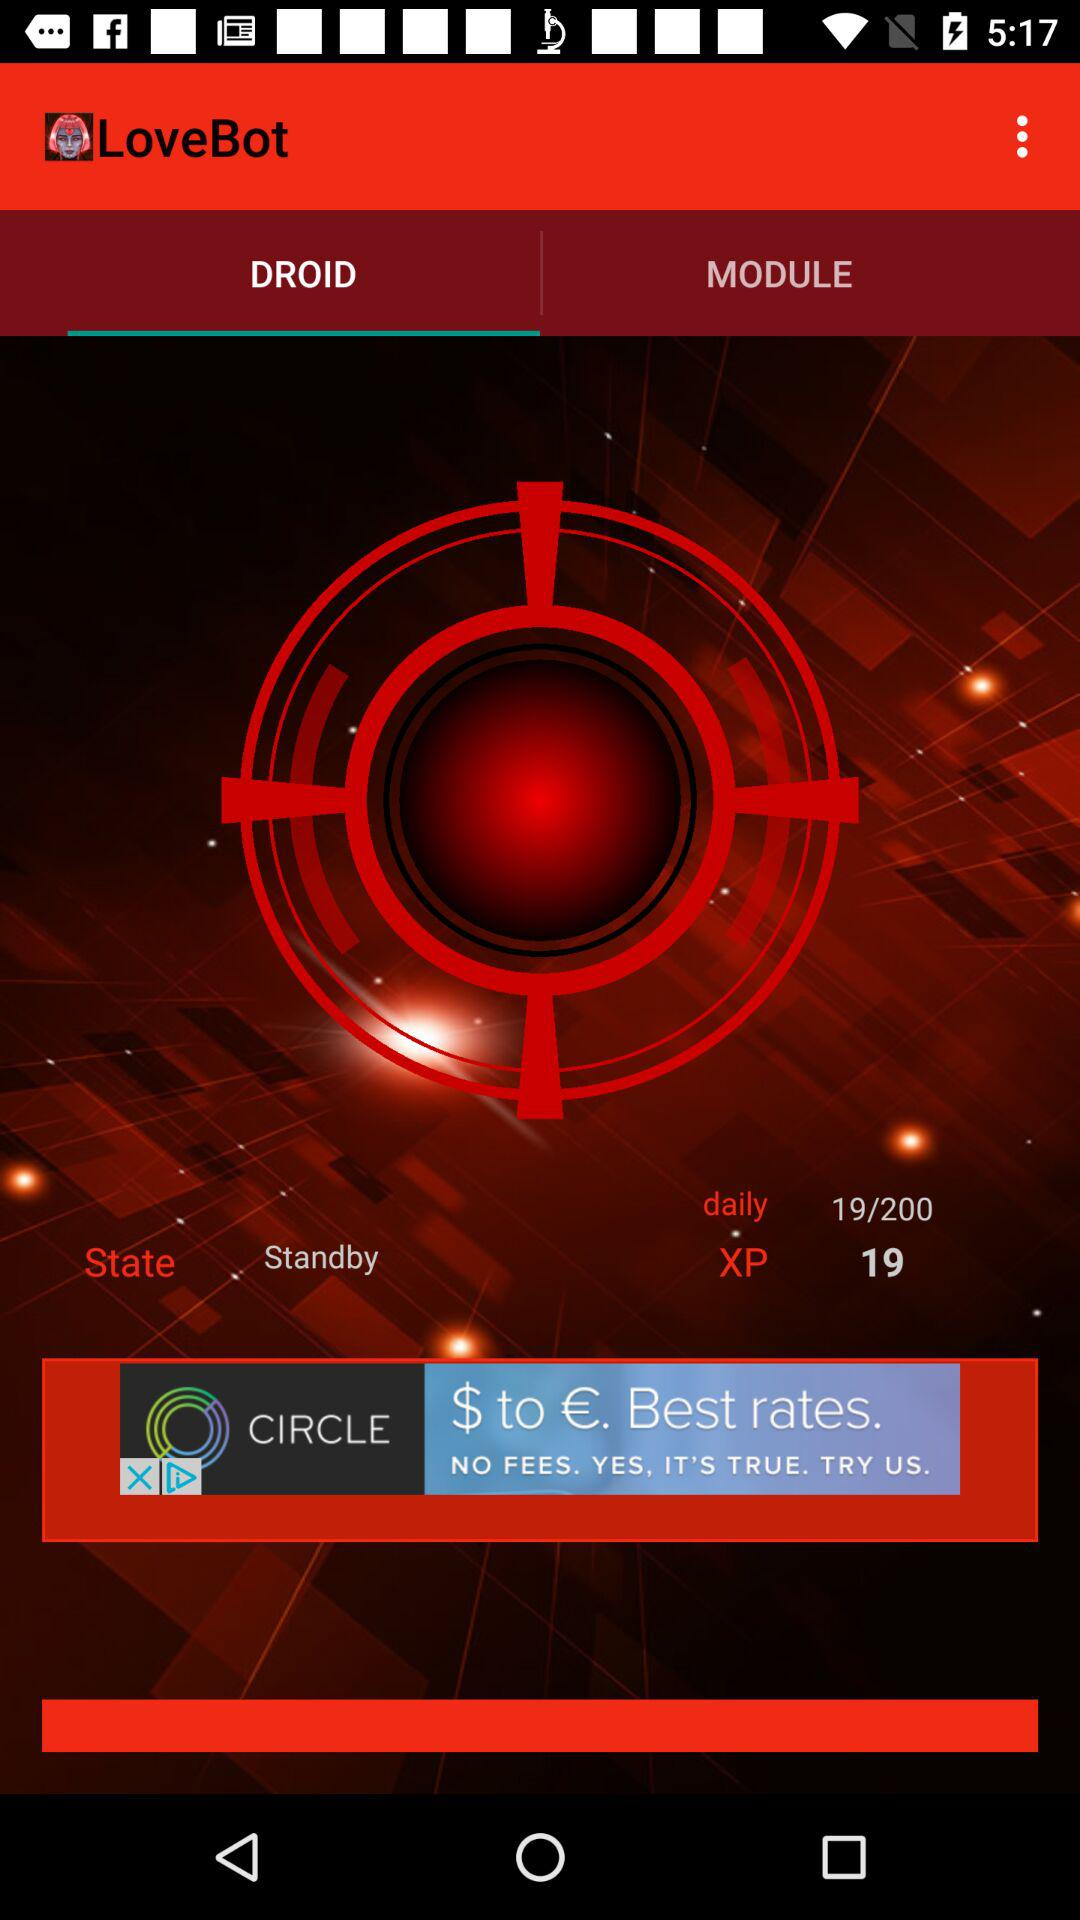Which tab is selected? The selected tab is "DROID". 